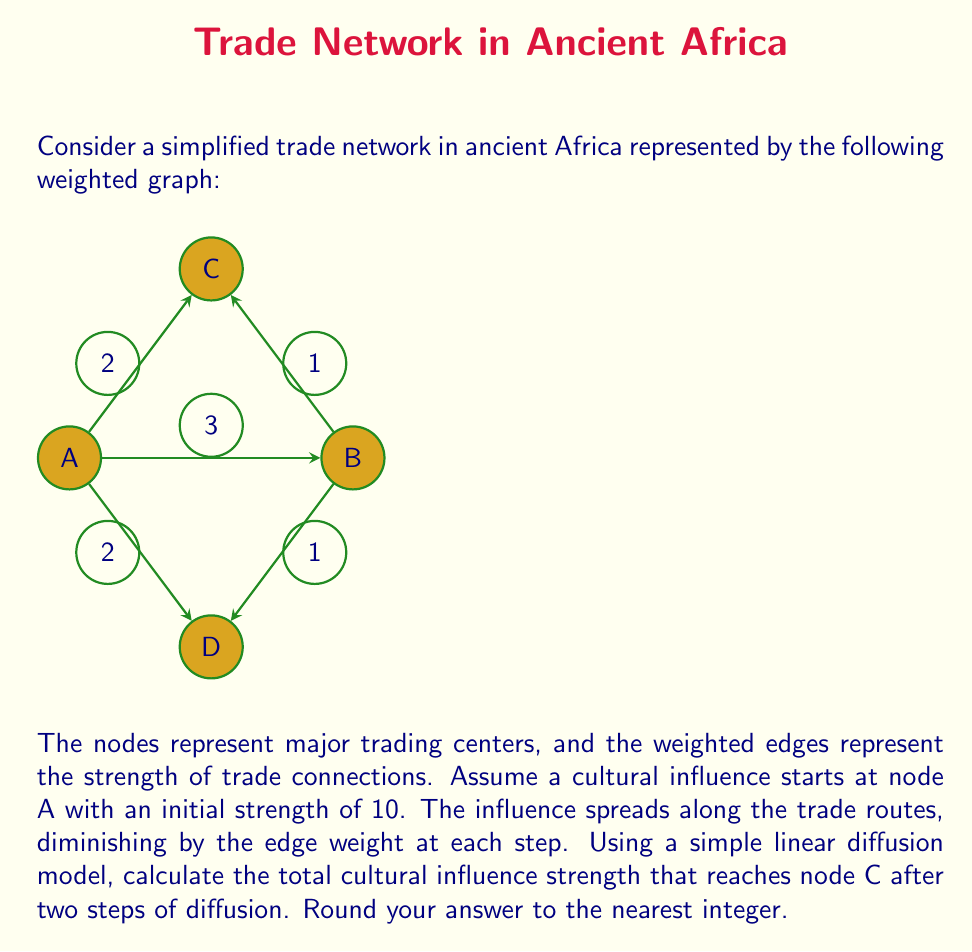Solve this math problem. Let's approach this step-by-step:

1) We need to consider all possible paths from A to C that are exactly two steps long.

2) There are two such paths:
   a) A → C directly (1 step)
   b) A → B → C (2 steps)

3) For path A → C:
   - Initial strength: 10
   - Edge weight: 2
   - Influence reaching C: $10 - 2 = 8$

4) For path A → B → C:
   - Initial strength: 10
   - First edge (A → B) weight: 3
   - Strength after first step: $10 - 3 = 7$
   - Second edge (B → C) weight: 1
   - Influence reaching C: $7 - 1 = 6$

5) The total influence reaching C is the sum of influences from both paths:
   $8 + 6 = 14$

6) Rounding to the nearest integer: 14

Therefore, the total cultural influence strength that reaches node C after two steps of diffusion is 14.
Answer: 14 